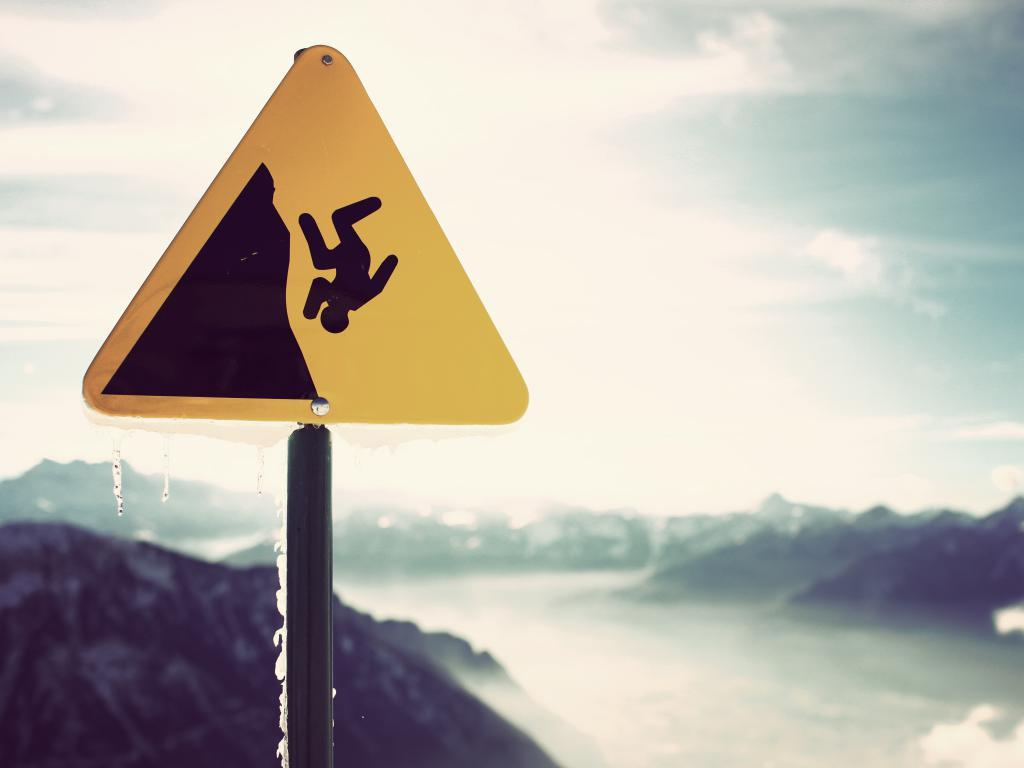What is the color of the signboard in the image? The signboard in the image is yellow. What is the signboard attached to? The signboard is attached to a black color pole. Is there any indication of snow in the image? Yes, there is snow on the signboard or pole in the image. What can be seen in the background of the image? There are mountains and clouds in the blue sky in the background of the image. What grade of expansion is required for the signboard to withstand the snow in the image? The image does not provide information about the grade of expansion required for the signboard. Additionally, the question assumes that the signboard needs to expand, which is not mentioned in the facts. 